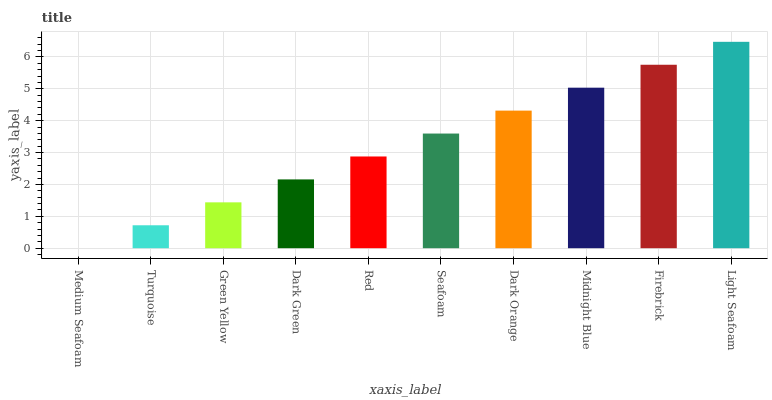Is Medium Seafoam the minimum?
Answer yes or no. Yes. Is Light Seafoam the maximum?
Answer yes or no. Yes. Is Turquoise the minimum?
Answer yes or no. No. Is Turquoise the maximum?
Answer yes or no. No. Is Turquoise greater than Medium Seafoam?
Answer yes or no. Yes. Is Medium Seafoam less than Turquoise?
Answer yes or no. Yes. Is Medium Seafoam greater than Turquoise?
Answer yes or no. No. Is Turquoise less than Medium Seafoam?
Answer yes or no. No. Is Seafoam the high median?
Answer yes or no. Yes. Is Red the low median?
Answer yes or no. Yes. Is Red the high median?
Answer yes or no. No. Is Firebrick the low median?
Answer yes or no. No. 